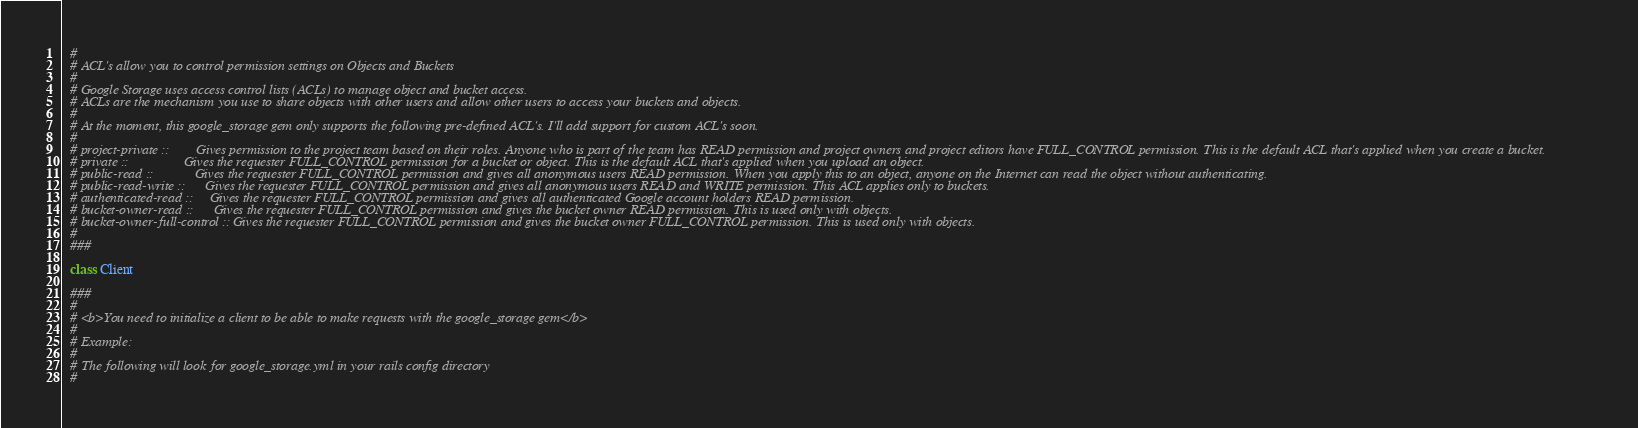Convert code to text. <code><loc_0><loc_0><loc_500><loc_500><_Ruby_>  #
  # ACL's allow you to control permission settings on Objects and Buckets
  #
  # Google Storage uses access control lists (ACLs) to manage object and bucket access.
  # ACLs are the mechanism you use to share objects with other users and allow other users to access your buckets and objects.
  #
  # At the moment, this google_storage gem only supports the following pre-defined ACL's. I'll add support for custom ACL's soon.
  #
  # project-private ::        Gives permission to the project team based on their roles. Anyone who is part of the team has READ permission and project owners and project editors have FULL_CONTROL permission. This is the default ACL that's applied when you create a bucket.
  # private ::                Gives the requester FULL_CONTROL permission for a bucket or object. This is the default ACL that's applied when you upload an object.
  # public-read ::            Gives the requester FULL_CONTROL permission and gives all anonymous users READ permission. When you apply this to an object, anyone on the Internet can read the object without authenticating.
  # public-read-write ::      Gives the requester FULL_CONTROL permission and gives all anonymous users READ and WRITE permission. This ACL applies only to buckets.
  # authenticated-read ::     Gives the requester FULL_CONTROL permission and gives all authenticated Google account holders READ permission.
  # bucket-owner-read ::      Gives the requester FULL_CONTROL permission and gives the bucket owner READ permission. This is used only with objects.
  # bucket-owner-full-control :: Gives the requester FULL_CONTROL permission and gives the bucket owner FULL_CONTROL permission. This is used only with objects.
  #
  ###
  
  class Client

  ###
  #
  # <b>You need to initialize a client to be able to make requests with the google_storage gem</b>
  #
  # Example:
  #
  # The following will look for google_storage.yml in your rails config directory
  #</code> 